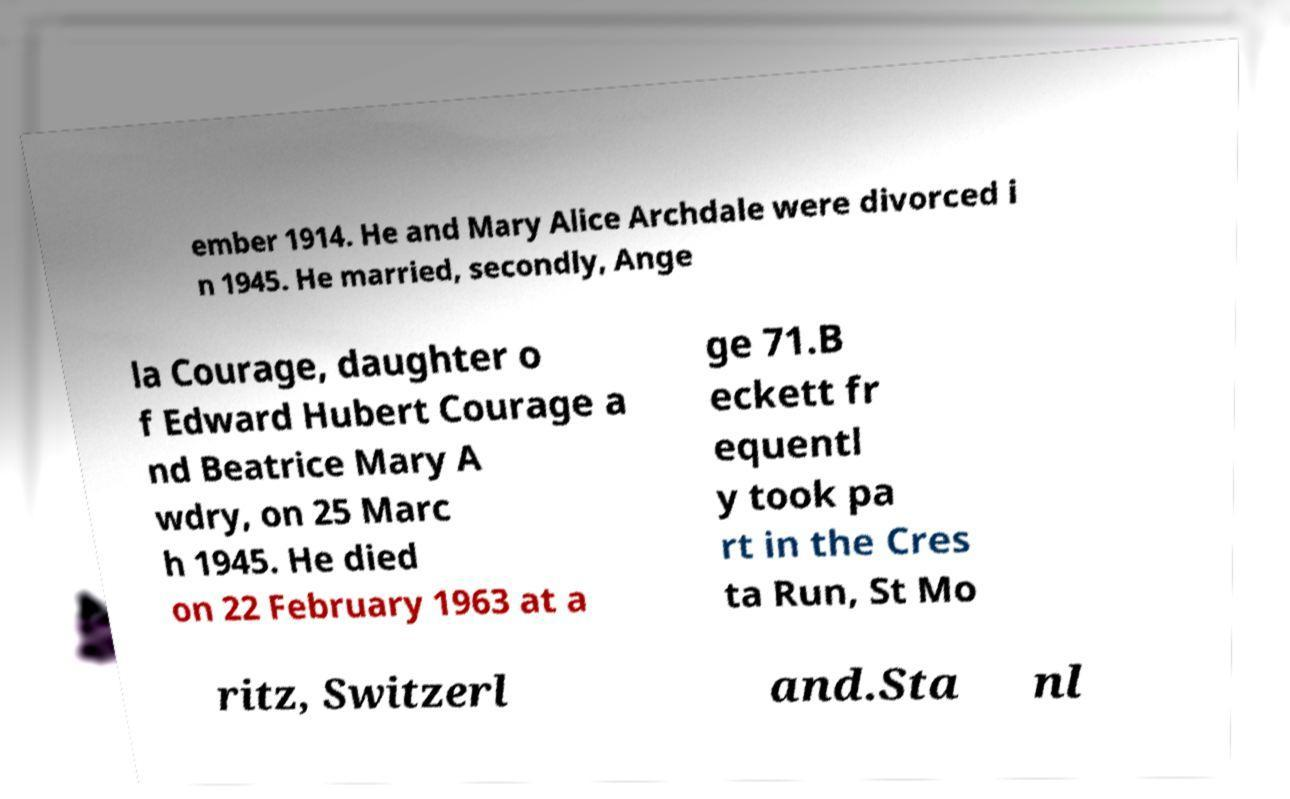For documentation purposes, I need the text within this image transcribed. Could you provide that? ember 1914. He and Mary Alice Archdale were divorced i n 1945. He married, secondly, Ange la Courage, daughter o f Edward Hubert Courage a nd Beatrice Mary A wdry, on 25 Marc h 1945. He died on 22 February 1963 at a ge 71.B eckett fr equentl y took pa rt in the Cres ta Run, St Mo ritz, Switzerl and.Sta nl 